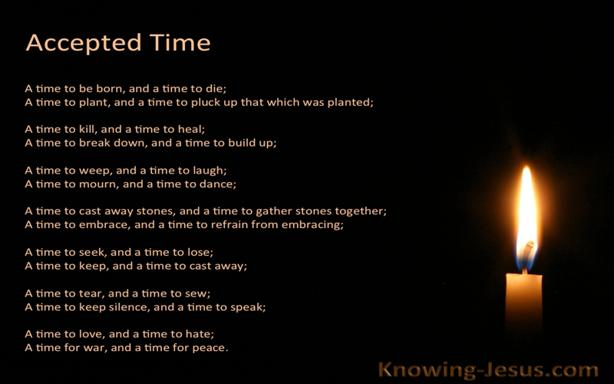What text is the quote from the image referencing? The quote in the image comes from the Bible, more specifically, the book of Ecclesiastes 3:1-8. This passage poetically outlines various seasons and essential actions in human life, signifying that each action has its allotted time and moral significance under heaven. It's often cited in discussions about the natural rhythms of life and finding purpose in our actions. 